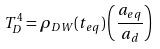Convert formula to latex. <formula><loc_0><loc_0><loc_500><loc_500>T _ { D } ^ { 4 } = \rho _ { D W } ( t _ { e q } ) \left ( \frac { a _ { e q } } { a _ { d } } \right )</formula> 